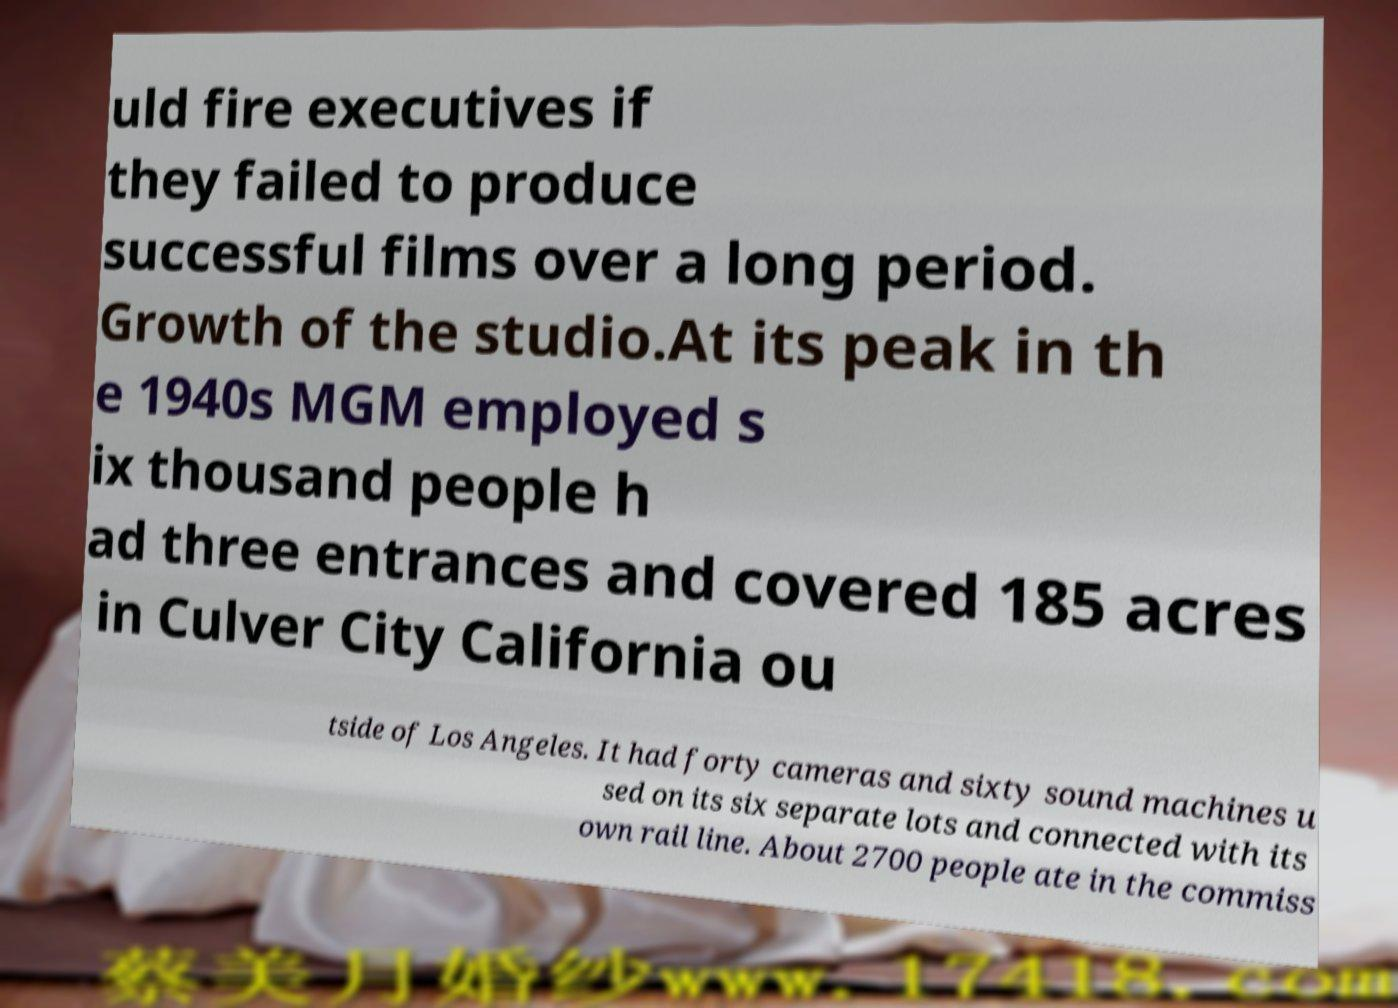Please identify and transcribe the text found in this image. uld fire executives if they failed to produce successful films over a long period. Growth of the studio.At its peak in th e 1940s MGM employed s ix thousand people h ad three entrances and covered 185 acres in Culver City California ou tside of Los Angeles. It had forty cameras and sixty sound machines u sed on its six separate lots and connected with its own rail line. About 2700 people ate in the commiss 